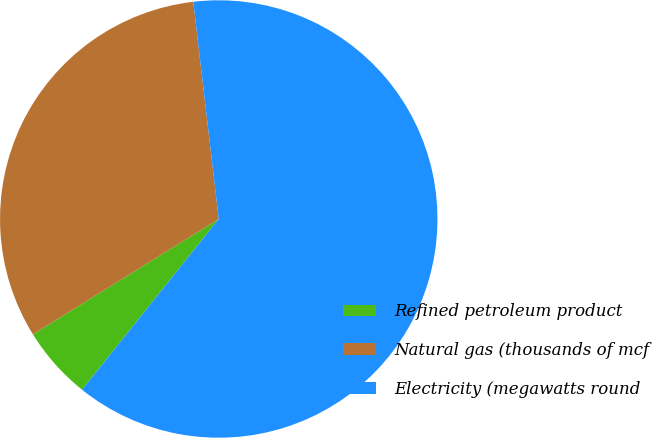Convert chart. <chart><loc_0><loc_0><loc_500><loc_500><pie_chart><fcel>Refined petroleum product<fcel>Natural gas (thousands of mcf<fcel>Electricity (megawatts round<nl><fcel>5.41%<fcel>31.99%<fcel>62.6%<nl></chart> 